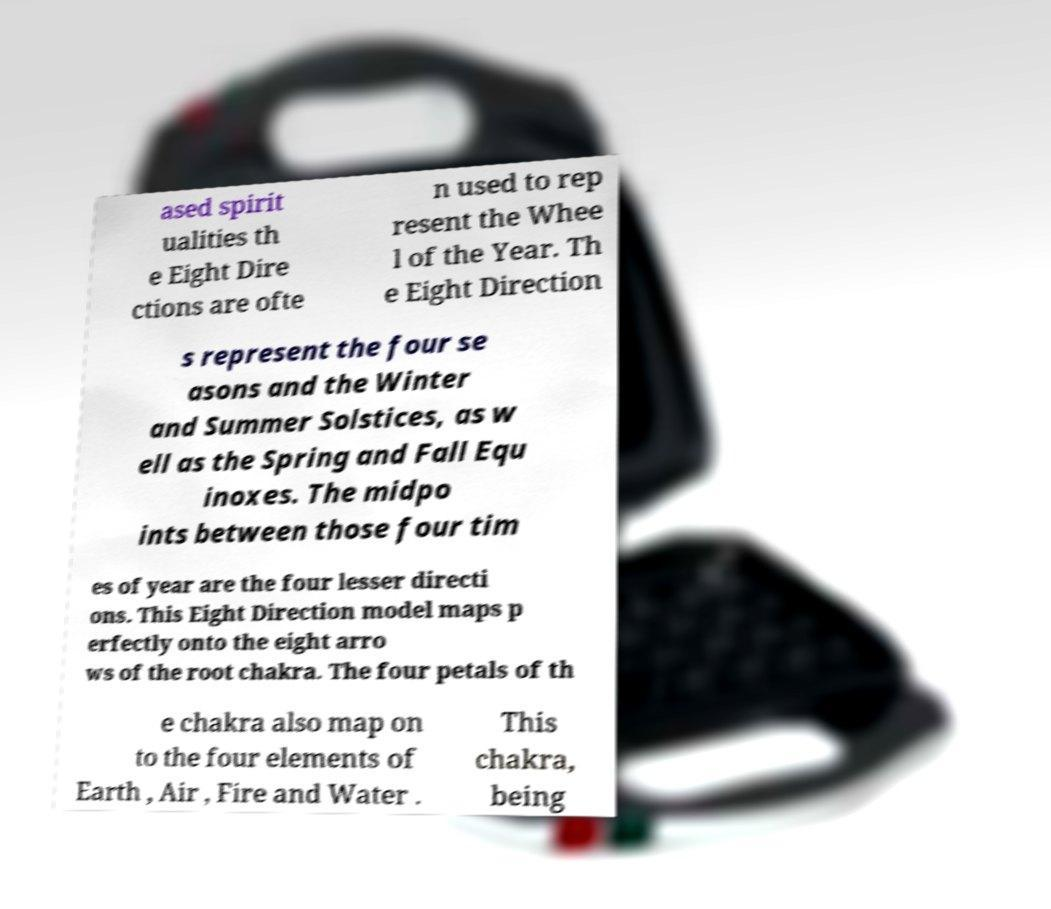Can you read and provide the text displayed in the image?This photo seems to have some interesting text. Can you extract and type it out for me? ased spirit ualities th e Eight Dire ctions are ofte n used to rep resent the Whee l of the Year. Th e Eight Direction s represent the four se asons and the Winter and Summer Solstices, as w ell as the Spring and Fall Equ inoxes. The midpo ints between those four tim es of year are the four lesser directi ons. This Eight Direction model maps p erfectly onto the eight arro ws of the root chakra. The four petals of th e chakra also map on to the four elements of Earth , Air , Fire and Water . This chakra, being 